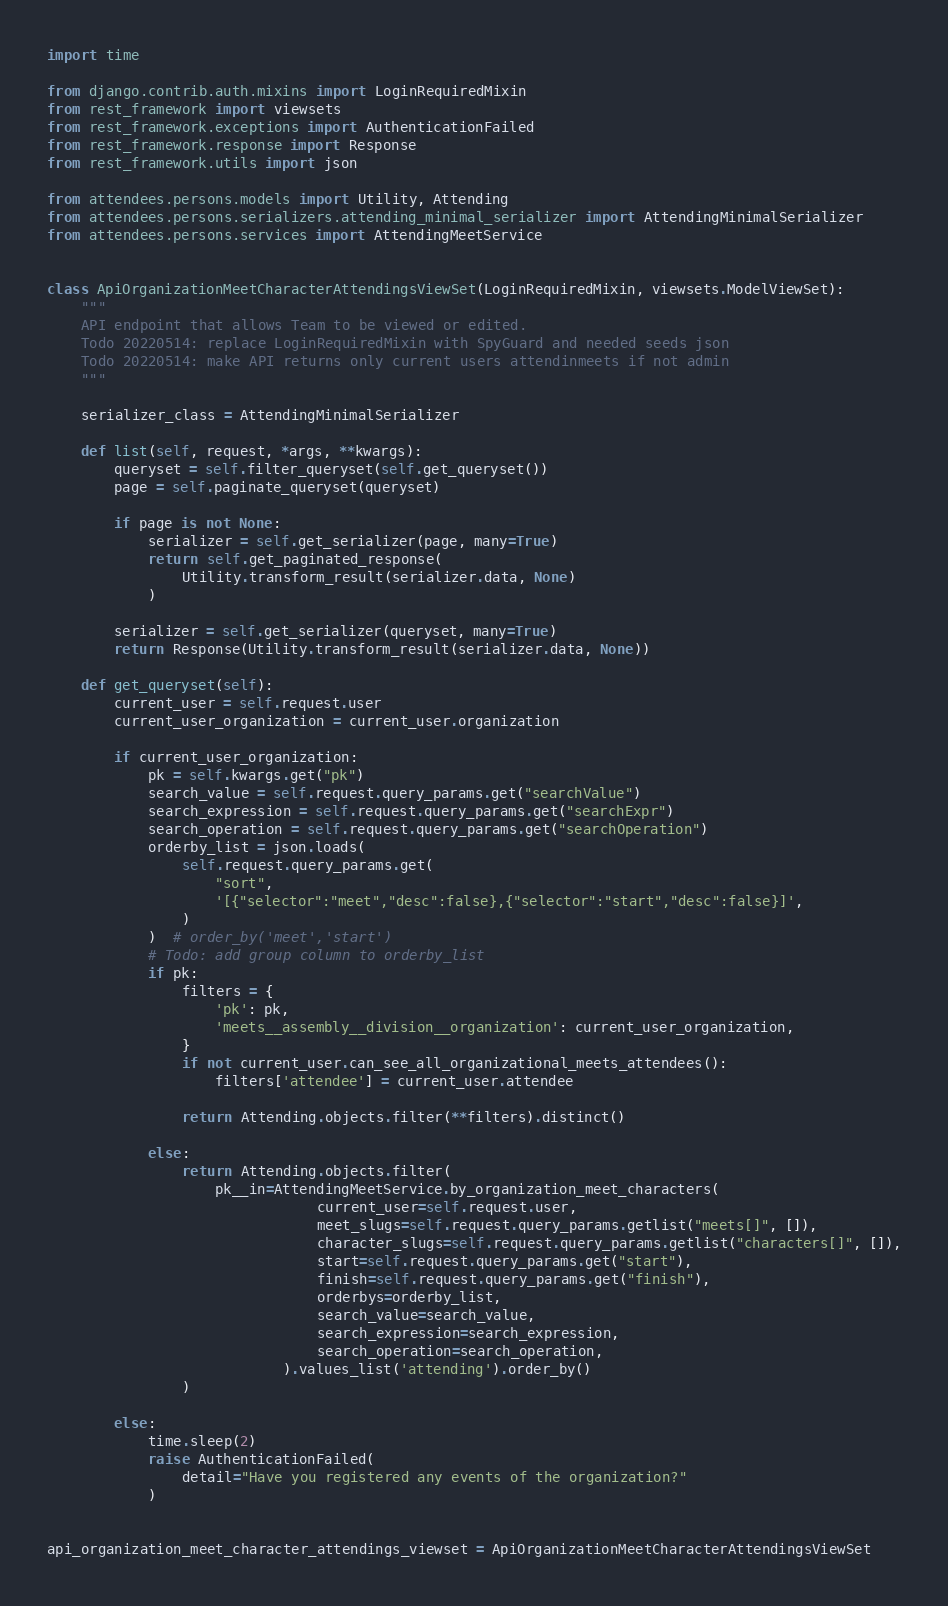Convert code to text. <code><loc_0><loc_0><loc_500><loc_500><_Python_>import time

from django.contrib.auth.mixins import LoginRequiredMixin
from rest_framework import viewsets
from rest_framework.exceptions import AuthenticationFailed
from rest_framework.response import Response
from rest_framework.utils import json

from attendees.persons.models import Utility, Attending
from attendees.persons.serializers.attending_minimal_serializer import AttendingMinimalSerializer
from attendees.persons.services import AttendingMeetService


class ApiOrganizationMeetCharacterAttendingsViewSet(LoginRequiredMixin, viewsets.ModelViewSet):
    """
    API endpoint that allows Team to be viewed or edited.
    Todo 20220514: replace LoginRequiredMixin with SpyGuard and needed seeds json
    Todo 20220514: make API returns only current users attendinmeets if not admin
    """

    serializer_class = AttendingMinimalSerializer

    def list(self, request, *args, **kwargs):
        queryset = self.filter_queryset(self.get_queryset())
        page = self.paginate_queryset(queryset)

        if page is not None:
            serializer = self.get_serializer(page, many=True)
            return self.get_paginated_response(
                Utility.transform_result(serializer.data, None)
            )

        serializer = self.get_serializer(queryset, many=True)
        return Response(Utility.transform_result(serializer.data, None))

    def get_queryset(self):
        current_user = self.request.user
        current_user_organization = current_user.organization

        if current_user_organization:
            pk = self.kwargs.get("pk")
            search_value = self.request.query_params.get("searchValue")
            search_expression = self.request.query_params.get("searchExpr")
            search_operation = self.request.query_params.get("searchOperation")
            orderby_list = json.loads(
                self.request.query_params.get(
                    "sort",
                    '[{"selector":"meet","desc":false},{"selector":"start","desc":false}]',
                )
            )  # order_by('meet','start')
            # Todo: add group column to orderby_list
            if pk:
                filters = {
                    'pk': pk,
                    'meets__assembly__division__organization': current_user_organization,
                }
                if not current_user.can_see_all_organizational_meets_attendees():
                    filters['attendee'] = current_user.attendee

                return Attending.objects.filter(**filters).distinct()

            else:
                return Attending.objects.filter(
                    pk__in=AttendingMeetService.by_organization_meet_characters(
                                current_user=self.request.user,
                                meet_slugs=self.request.query_params.getlist("meets[]", []),
                                character_slugs=self.request.query_params.getlist("characters[]", []),
                                start=self.request.query_params.get("start"),
                                finish=self.request.query_params.get("finish"),
                                orderbys=orderby_list,
                                search_value=search_value,
                                search_expression=search_expression,
                                search_operation=search_operation,
                            ).values_list('attending').order_by()
                )

        else:
            time.sleep(2)
            raise AuthenticationFailed(
                detail="Have you registered any events of the organization?"
            )


api_organization_meet_character_attendings_viewset = ApiOrganizationMeetCharacterAttendingsViewSet
</code> 